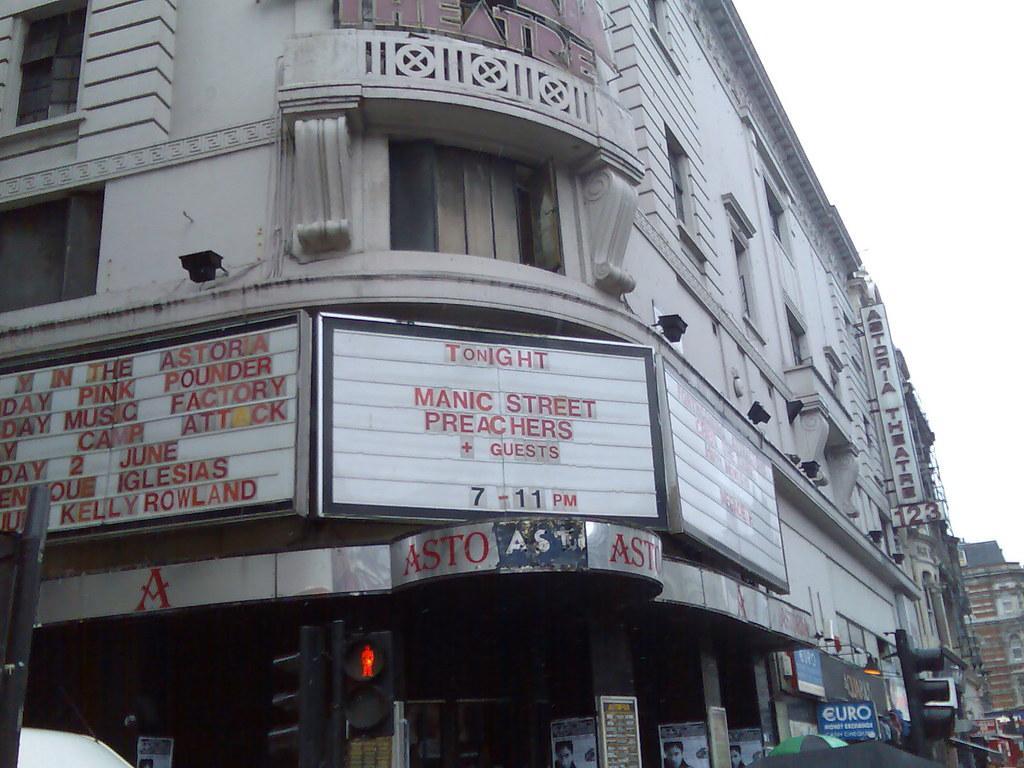Please provide a concise description of this image. In this image, there is a building, on that building there are some white color boards, on the white color board, there is TONIGHT MANIC STREET written, there is a black color signal light, at the right side top there is a sky. 